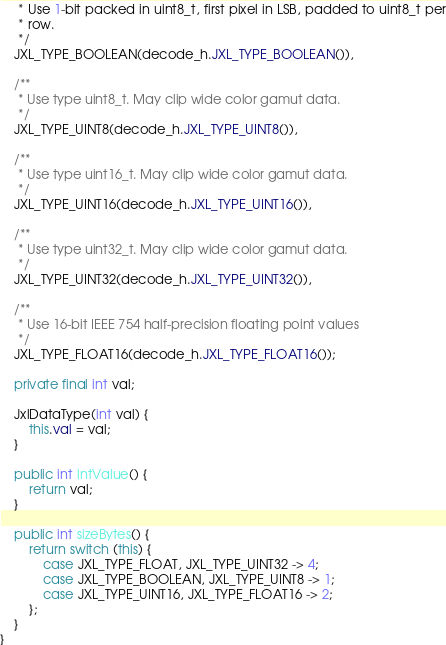Convert code to text. <code><loc_0><loc_0><loc_500><loc_500><_Java_>     * Use 1-bit packed in uint8_t, first pixel in LSB, padded to uint8_t per
     * row.
     */
    JXL_TYPE_BOOLEAN(decode_h.JXL_TYPE_BOOLEAN()),

    /**
     * Use type uint8_t. May clip wide color gamut data.
     */
    JXL_TYPE_UINT8(decode_h.JXL_TYPE_UINT8()),

    /**
     * Use type uint16_t. May clip wide color gamut data.
     */
    JXL_TYPE_UINT16(decode_h.JXL_TYPE_UINT16()),

    /**
     * Use type uint32_t. May clip wide color gamut data.
     */
    JXL_TYPE_UINT32(decode_h.JXL_TYPE_UINT32()),

    /**
     * Use 16-bit IEEE 754 half-precision floating point values
     */
    JXL_TYPE_FLOAT16(decode_h.JXL_TYPE_FLOAT16());

    private final int val;

    JxlDataType(int val) {
        this.val = val;
    }

    public int intValue() {
        return val;
    }

    public int sizeBytes() {
        return switch (this) {
            case JXL_TYPE_FLOAT, JXL_TYPE_UINT32 -> 4;
            case JXL_TYPE_BOOLEAN, JXL_TYPE_UINT8 -> 1;
            case JXL_TYPE_UINT16, JXL_TYPE_FLOAT16 -> 2;
        };
    }
}
</code> 